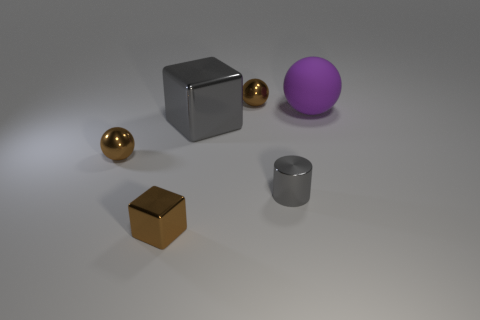Is there any other thing that has the same material as the large purple ball?
Make the answer very short. No. Is the shiny cylinder the same color as the large shiny cube?
Provide a short and direct response. Yes. Is the size of the brown shiny thing behind the matte thing the same as the large matte thing?
Make the answer very short. No. Are there any other things that have the same shape as the small gray thing?
Your answer should be very brief. No. Do the gray cylinder and the big gray thing in front of the rubber object have the same material?
Give a very brief answer. Yes. How many gray objects are either cubes or big rubber balls?
Ensure brevity in your answer.  1. Is there a cyan cube?
Ensure brevity in your answer.  No. Are there any spheres that are in front of the gray metallic object left of the object that is behind the big matte sphere?
Your answer should be very brief. Yes. There is a purple object; does it have the same shape as the tiny brown metal thing behind the big matte sphere?
Keep it short and to the point. Yes. There is a sphere that is in front of the large purple matte thing behind the gray object on the left side of the small metallic cylinder; what color is it?
Ensure brevity in your answer.  Brown. 